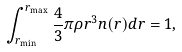Convert formula to latex. <formula><loc_0><loc_0><loc_500><loc_500>\int _ { r _ { \min } } ^ { r _ { \max } } \frac { 4 } { 3 } \pi \rho r ^ { 3 } n ( r ) d r = 1 ,</formula> 